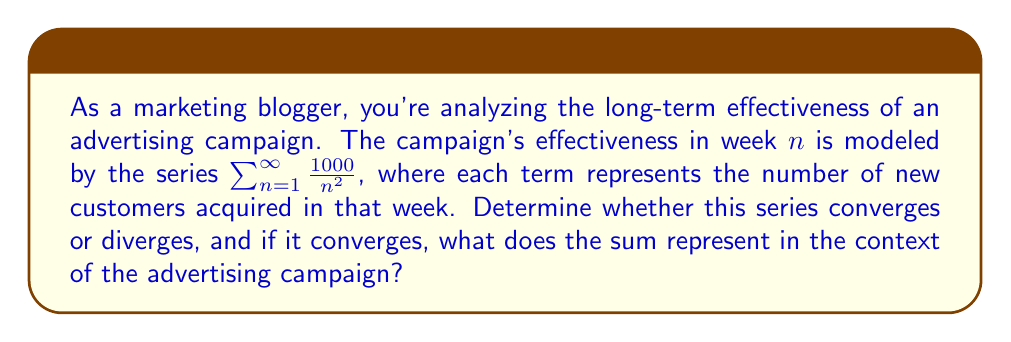Could you help me with this problem? To determine the convergence of the series $\sum_{n=1}^{\infty} \frac{1000}{n^2}$, we can use the p-series test:

1) First, recognize that this is a p-series of the form $\sum_{n=1}^{\infty} \frac{a}{n^p}$, where $a = 1000$ and $p = 2$.

2) For a p-series, we know that:
   - If $p > 1$, the series converges
   - If $p \leq 1$, the series diverges

3) In this case, $p = 2$, which is greater than 1.

4) Therefore, the series converges.

5) To find the sum of this convergent series, we can use the fact that:

   $$\sum_{n=1}^{\infty} \frac{1}{n^2} = \frac{\pi^2}{6}$$

6) Our series is 1000 times this value:

   $$1000 \cdot \sum_{n=1}^{\infty} \frac{1}{n^2} = 1000 \cdot \frac{\pi^2}{6} \approx 1644.93$$

In the context of the advertising campaign, this means that the total number of new customers acquired over the entire duration of the campaign (assuming it continues indefinitely) is approximately 1645. The convergence indicates that the campaign's effectiveness diminishes over time, but the total impact has a finite limit.
Answer: The series converges to $1000 \cdot \frac{\pi^2}{6} \approx 1645$ new customers. 